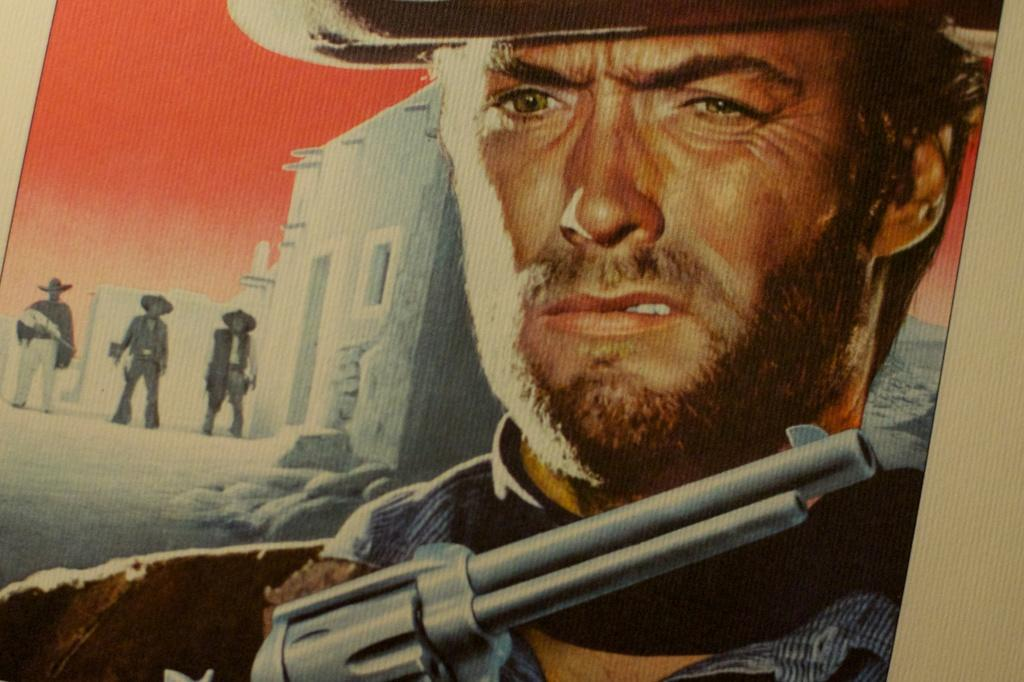What is depicted on the poster in the image? The poster features a man holding a gun. What can be seen in the background of the image? There are buildings visible in the background of the image. How many people are standing in the background of the image? There are three persons standing in the background of the image. What type of button can be seen on the man's chin in the image? There is no button visible on the man's chin in the image, as the man is holding a gun and not wearing any clothing that would have a button. How does the jelly interact with the poster in the image? There is no jelly present in the image, so it cannot interact with the poster. 